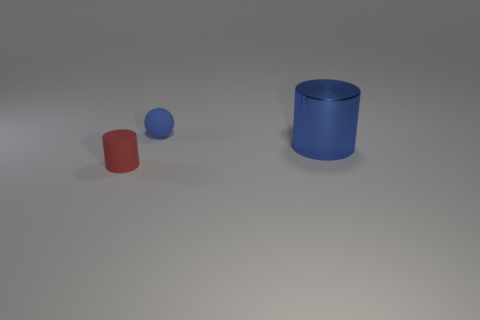Add 3 big blue cylinders. How many objects exist? 6 Subtract all cylinders. How many objects are left? 1 Add 3 small blue rubber objects. How many small blue rubber objects exist? 4 Subtract 0 purple cubes. How many objects are left? 3 Subtract all brown matte objects. Subtract all rubber objects. How many objects are left? 1 Add 2 tiny spheres. How many tiny spheres are left? 3 